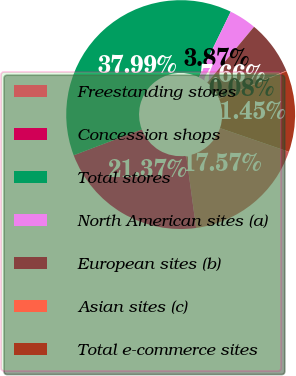Convert chart to OTSL. <chart><loc_0><loc_0><loc_500><loc_500><pie_chart><fcel>Freestanding stores<fcel>Concession shops<fcel>Total stores<fcel>North American sites (a)<fcel>European sites (b)<fcel>Asian sites (c)<fcel>Total e-commerce sites<nl><fcel>17.57%<fcel>21.37%<fcel>37.99%<fcel>3.87%<fcel>7.66%<fcel>0.08%<fcel>11.45%<nl></chart> 